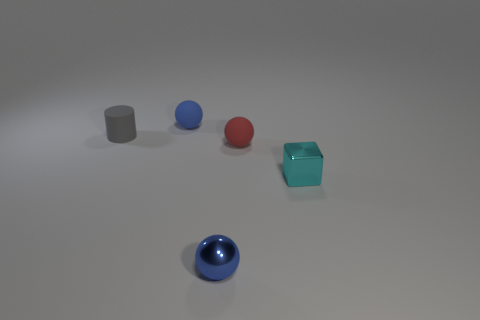Subtract all small red matte spheres. How many spheres are left? 2 Subtract all purple cylinders. How many blue balls are left? 2 Add 3 red things. How many objects exist? 8 Subtract 1 balls. How many balls are left? 2 Subtract all balls. How many objects are left? 2 Subtract 0 purple balls. How many objects are left? 5 Subtract all brown balls. Subtract all green cylinders. How many balls are left? 3 Subtract all matte cylinders. Subtract all blocks. How many objects are left? 3 Add 1 small gray rubber objects. How many small gray rubber objects are left? 2 Add 3 tiny red rubber cylinders. How many tiny red rubber cylinders exist? 3 